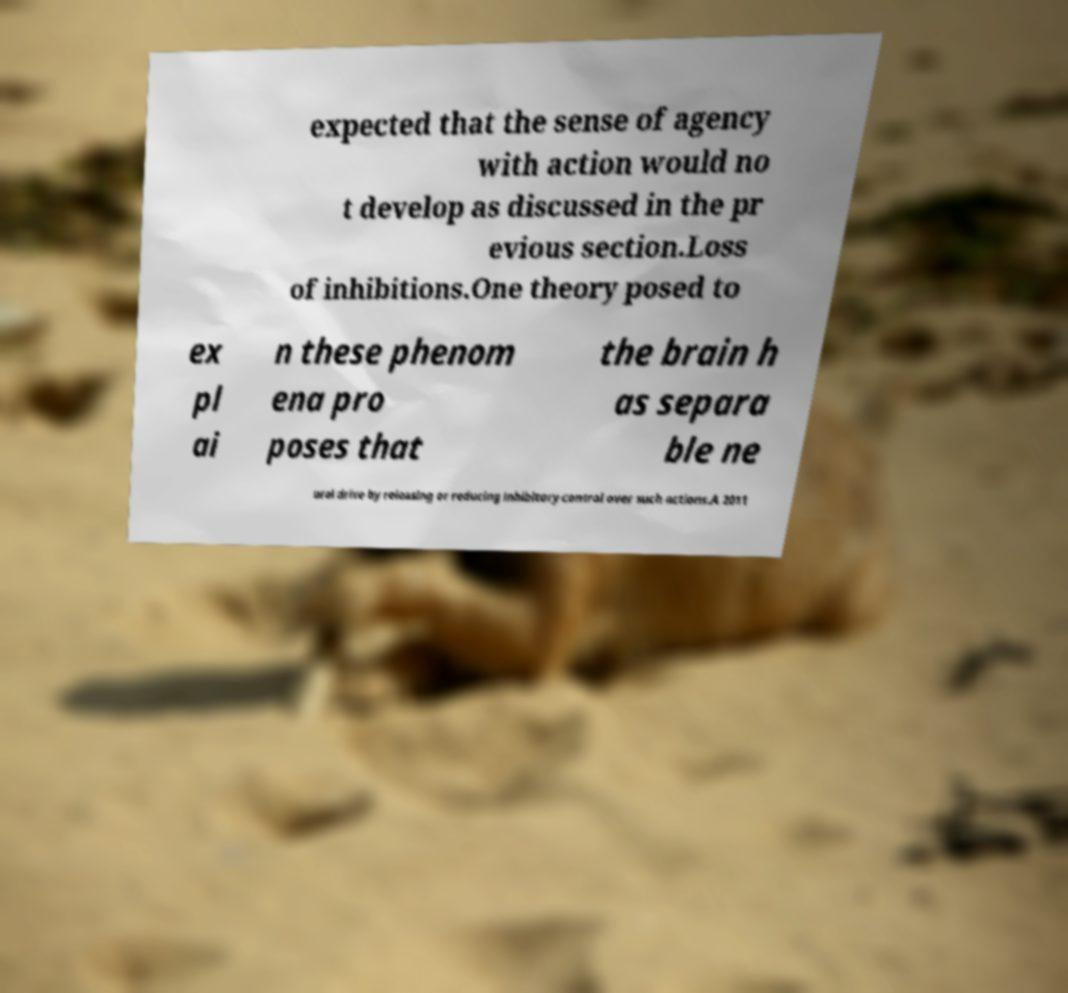Please read and relay the text visible in this image. What does it say? expected that the sense of agency with action would no t develop as discussed in the pr evious section.Loss of inhibitions.One theory posed to ex pl ai n these phenom ena pro poses that the brain h as separa ble ne ural drive by releasing or reducing inhibitory control over such actions.A 2011 